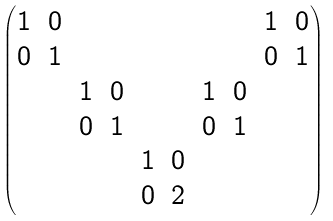Convert formula to latex. <formula><loc_0><loc_0><loc_500><loc_500>\begin{pmatrix} 1 & 0 & & & & & & & 1 & 0 \\ 0 & 1 & & & & & & & 0 & 1 \\ & & 1 & 0 & & & 1 & 0 \\ & & 0 & 1 & & & 0 & 1 \\ & & & & 1 & 0 & & & & \\ & & & & 0 & 2 & & & & \\ \end{pmatrix}</formula> 